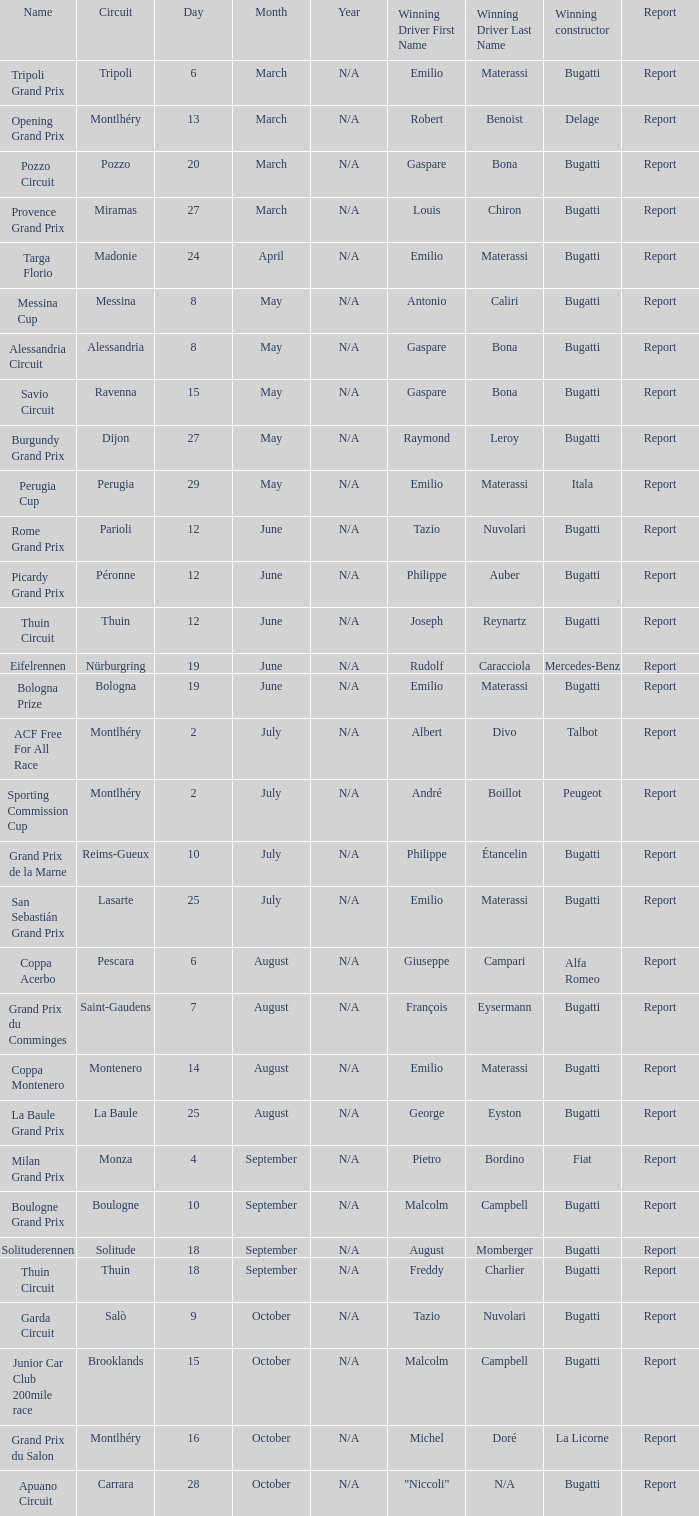Who was the winning constructor of the Grand Prix Du Salon ? La Licorne. 